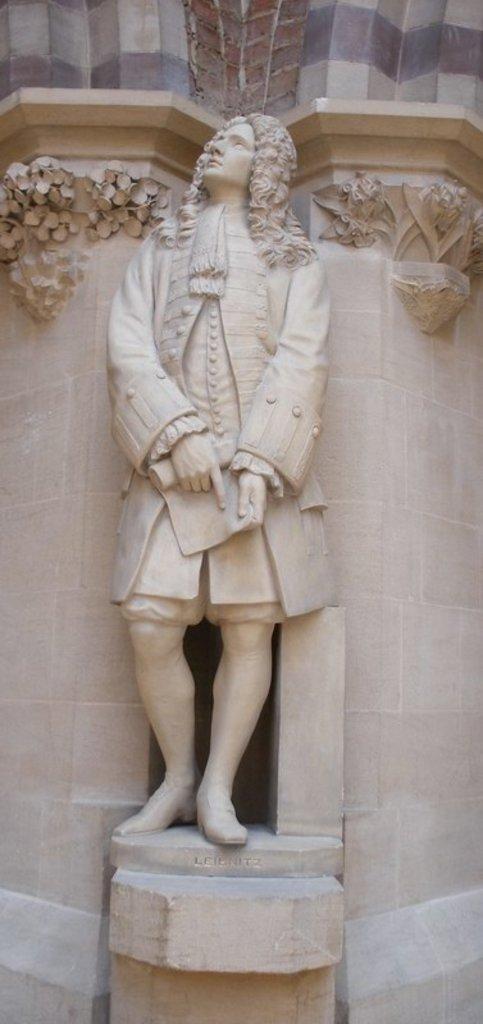Could you give a brief overview of what you see in this image? This is the sculpture of the man standing and holding a paper. These are the kind of pillars. I can see the design carved on the pillars. 